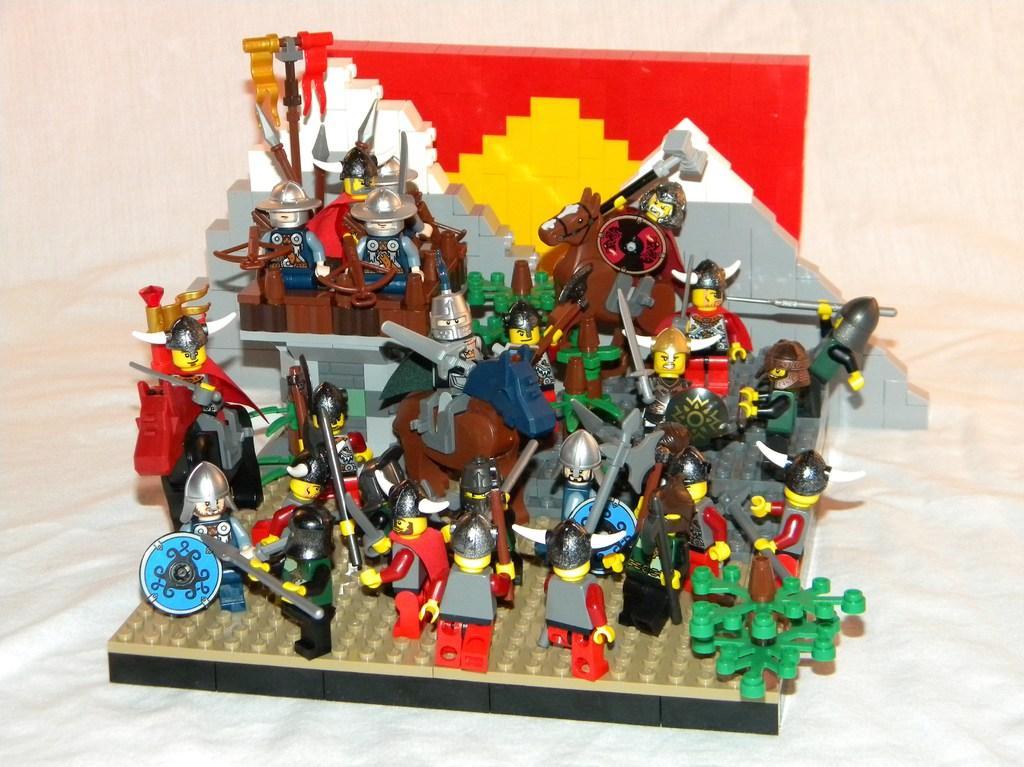Can you describe this image briefly? In this image there are toys in the center. 